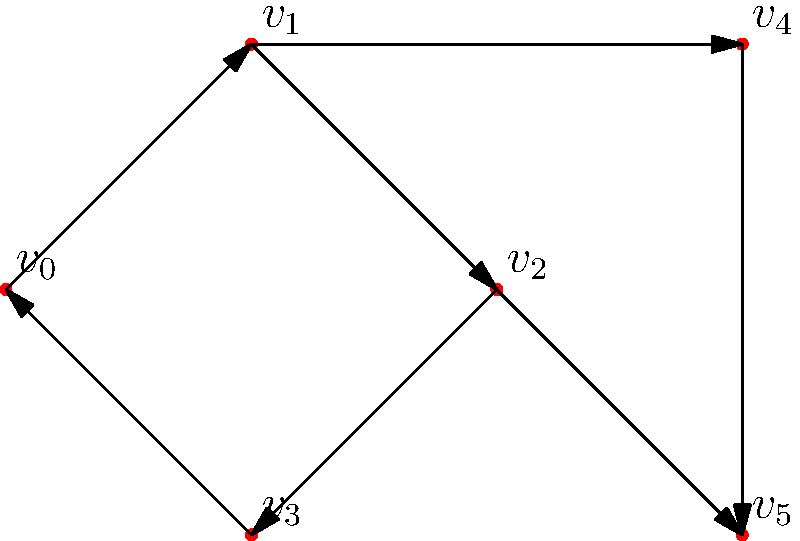Рассмотрите направленный граф, представленный на рисунке выше. Используя алгоритм поиска в глубину (DFS), определите количество циклов в графе. Объясните ваш подход и обоснуйте ответ. Для решения этой задачи мы будем использовать алгоритм поиска в глубину (DFS) для обнаружения циклов в направленном графе. Вот пошаговое объяснение:

1) Начнем с создания структуры данных для представления графа. В нашем случае это список смежности:
   
   $v_0: [v_1]$
   $v_1: [v_2, v_4]$
   $v_2: [v_3, v_5]$
   $v_3: [v_0]$
   $v_4: [v_5]$
   $v_5: []$

2) Реализуем DFS с отслеживанием вершин в текущем пути и посещенных вершин:

   - Используем два набора: один для вершин в текущем пути (path_set) и один для всех посещенных вершин (visited_set).
   - При входе в вершину добавляем ее в оба набора.
   - При выходе из вершины удаляем ее из path_set, но оставляем в visited_set.

3) Цикл обнаруживается, когда мы пытаемся посетить вершину, которая уже находится в path_set.

4) Применим DFS, начиная с каждой непосещенной вершины:

   - Начинаем с $v_0$: $v_0 \rightarrow v_1 \rightarrow v_2 \rightarrow v_3 \rightarrow v_0$ (цикл найден)
   - Продолжаем с $v_1$: $v_1 \rightarrow v_4 \rightarrow v_5$ (новый путь, но не цикл)
   - Все остальные вершины уже посещены

5) В итоге мы обнаружили один цикл: $v_0 \rightarrow v_1 \rightarrow v_2 \rightarrow v_3 \rightarrow v_0$

Важно отметить, что хотя визуально может показаться, что есть два цикла (включая $v_4 \rightarrow v_5$), на самом деле между $v_4$ и $v_5$ нет цикла, так как ребро направлено только в одну сторону.
Answer: 1 цикл 